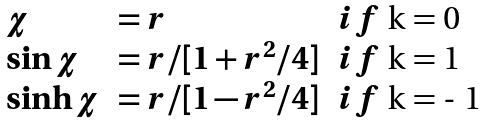Convert formula to latex. <formula><loc_0><loc_0><loc_500><loc_500>\begin{array} { l l l } \chi & = r & i f $ k = 0 $ \\ \sin \chi & = r / [ 1 + r ^ { 2 } / 4 ] & i f $ k = 1 $ \\ \sinh \chi & = r / [ 1 - r ^ { 2 } / 4 ] & i f $ k = - 1 $ \\ \end{array}</formula> 